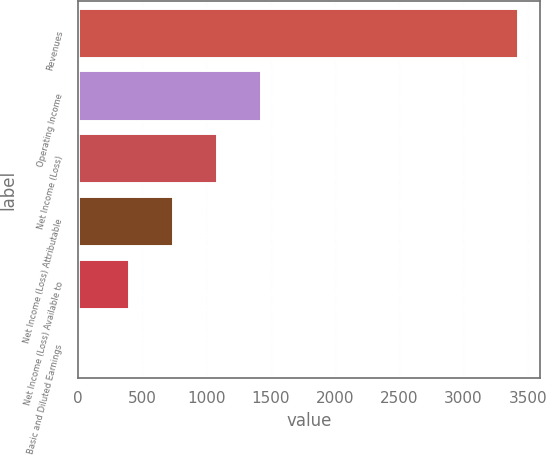Convert chart. <chart><loc_0><loc_0><loc_500><loc_500><bar_chart><fcel>Revenues<fcel>Operating Income<fcel>Net Income (Loss)<fcel>Net Income (Loss) Attributable<fcel>Net Income (Loss) Available to<fcel>Basic and Diluted Earnings<nl><fcel>3424<fcel>1428.14<fcel>1085.76<fcel>743.38<fcel>401<fcel>0.18<nl></chart> 